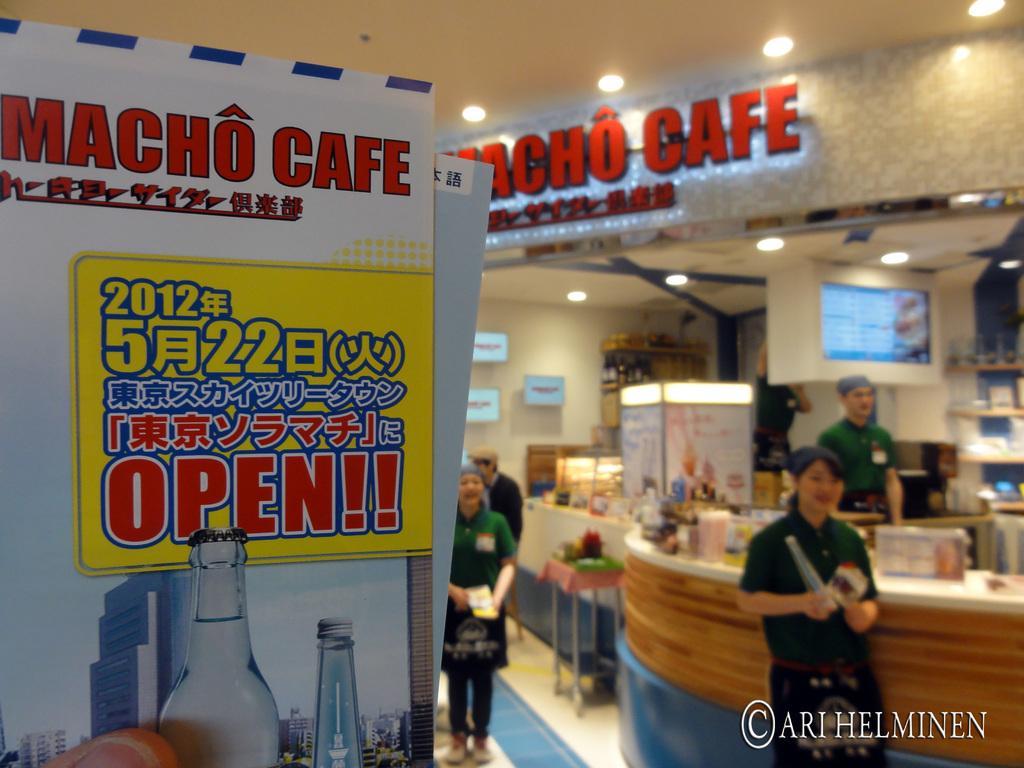Describe this image in one or two sentences. In the image on the left we can see banner named as "Macho Cafe". In the right we can see few persons were standing. In center again two persons were standing. And back there is a table,stool,few products,monitor,lights etc. 